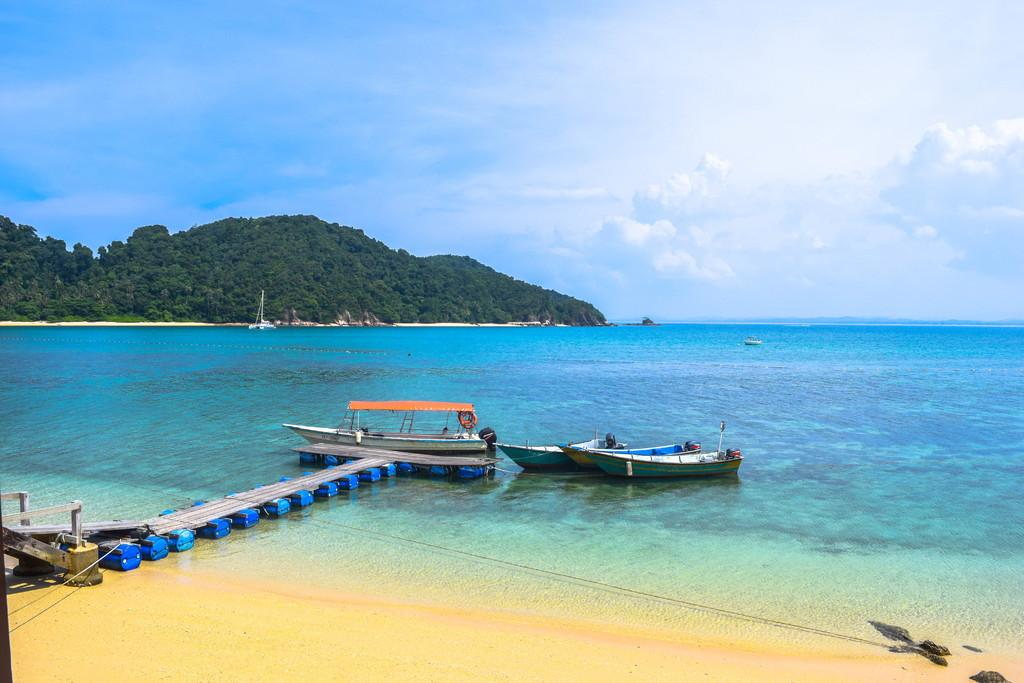What is located above the water in the image? There are boats above the water in the image. What type of pathway can be seen in the image? There is a walkway in the image. What can be seen in the background of the image? There are trees and the sky visible in the background of the image. What is present in the sky? Clouds are present in the sky. What type of tooth is visible in the image? There is no tooth present in the image. What thrilling activity is taking place in the image? There is no thrilling activity depicted in the image; it shows boats, a walkway, trees, and the sky. 